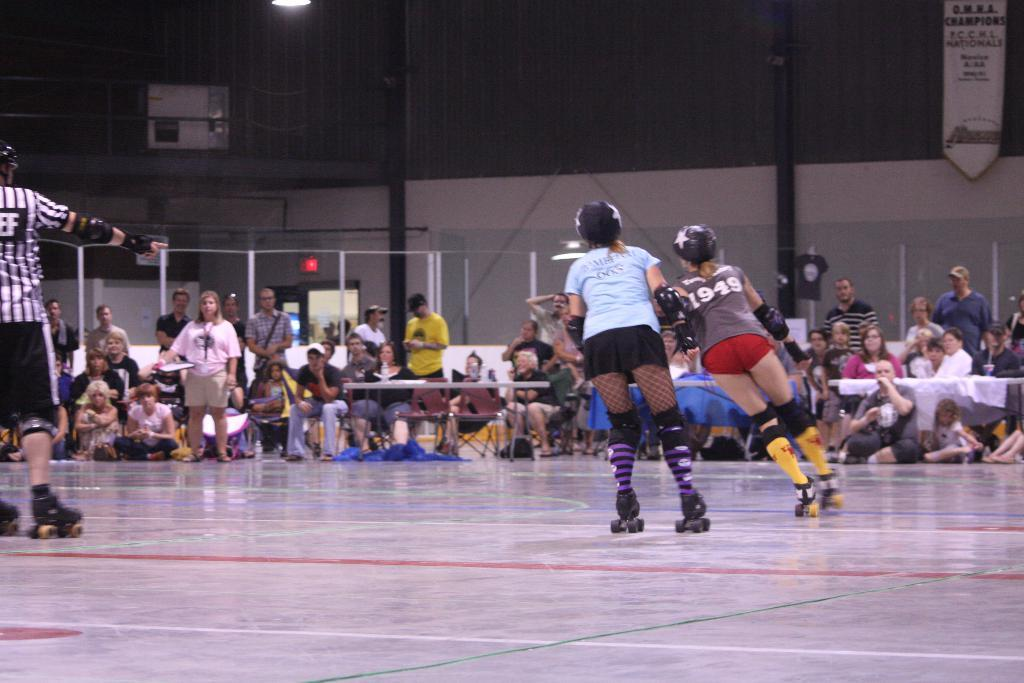What activity are the people in the image engaged in? The people in the image are doing skating on the floor. Where is the skating taking place? The skating is taking place inside a hall. What are the other people inside the hall doing? The other people inside the hall are sitting and standing. What type of breakfast is being served to the fireman in the image? There is no fireman or breakfast present in the image; it features people skating inside a hall. 